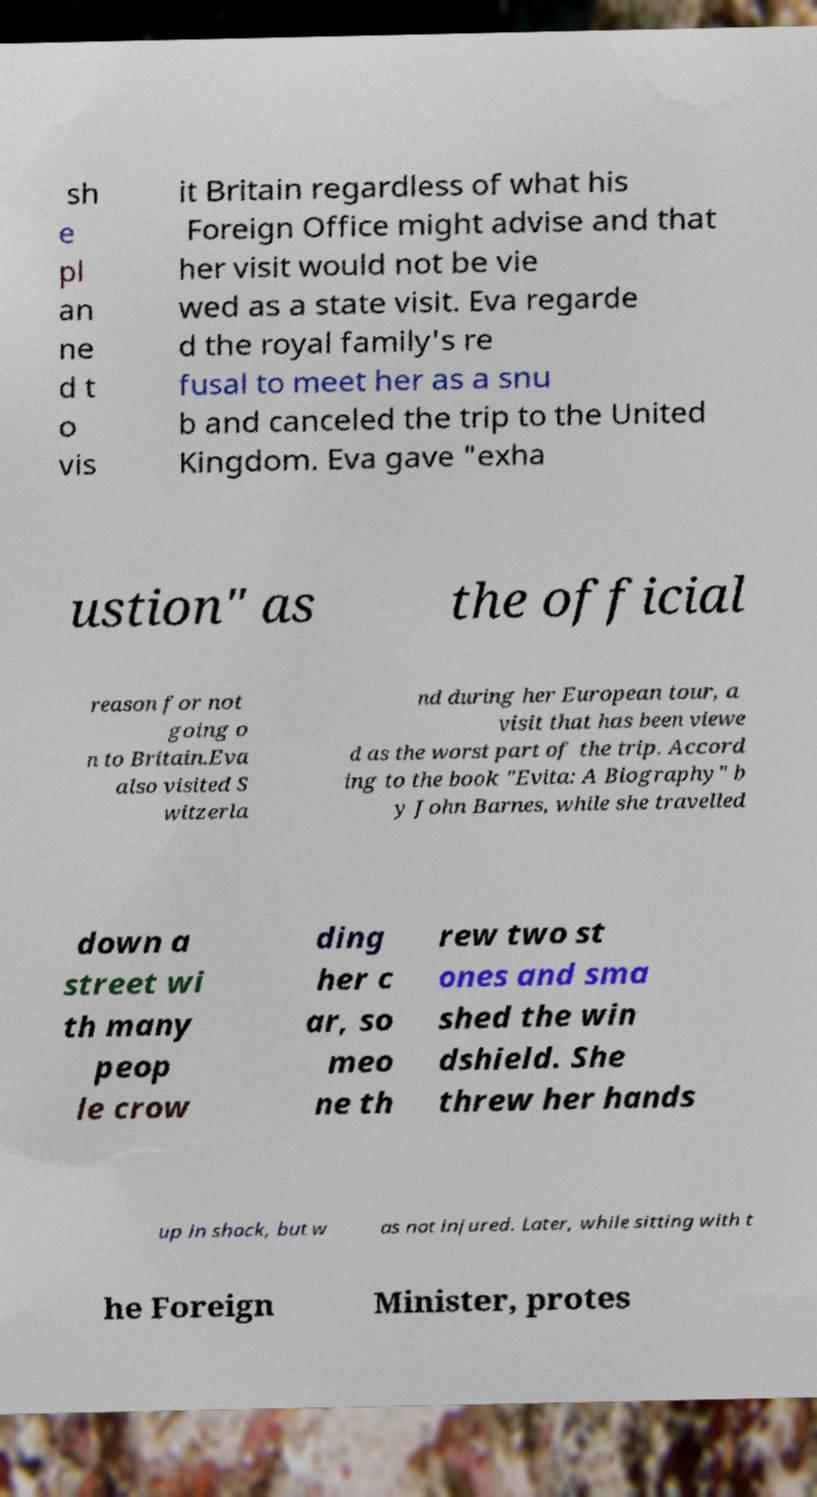Can you accurately transcribe the text from the provided image for me? sh e pl an ne d t o vis it Britain regardless of what his Foreign Office might advise and that her visit would not be vie wed as a state visit. Eva regarde d the royal family's re fusal to meet her as a snu b and canceled the trip to the United Kingdom. Eva gave "exha ustion" as the official reason for not going o n to Britain.Eva also visited S witzerla nd during her European tour, a visit that has been viewe d as the worst part of the trip. Accord ing to the book "Evita: A Biography" b y John Barnes, while she travelled down a street wi th many peop le crow ding her c ar, so meo ne th rew two st ones and sma shed the win dshield. She threw her hands up in shock, but w as not injured. Later, while sitting with t he Foreign Minister, protes 